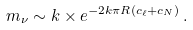Convert formula to latex. <formula><loc_0><loc_0><loc_500><loc_500>m _ { \nu } \sim k \times e ^ { - 2 k \pi R ( c _ { \ell } + c _ { N } ) } \, .</formula> 